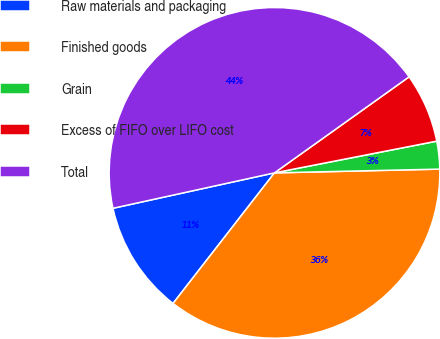Convert chart to OTSL. <chart><loc_0><loc_0><loc_500><loc_500><pie_chart><fcel>Raw materials and packaging<fcel>Finished goods<fcel>Grain<fcel>Excess of FIFO over LIFO cost<fcel>Total<nl><fcel>11.05%<fcel>35.87%<fcel>2.71%<fcel>6.79%<fcel>43.57%<nl></chart> 